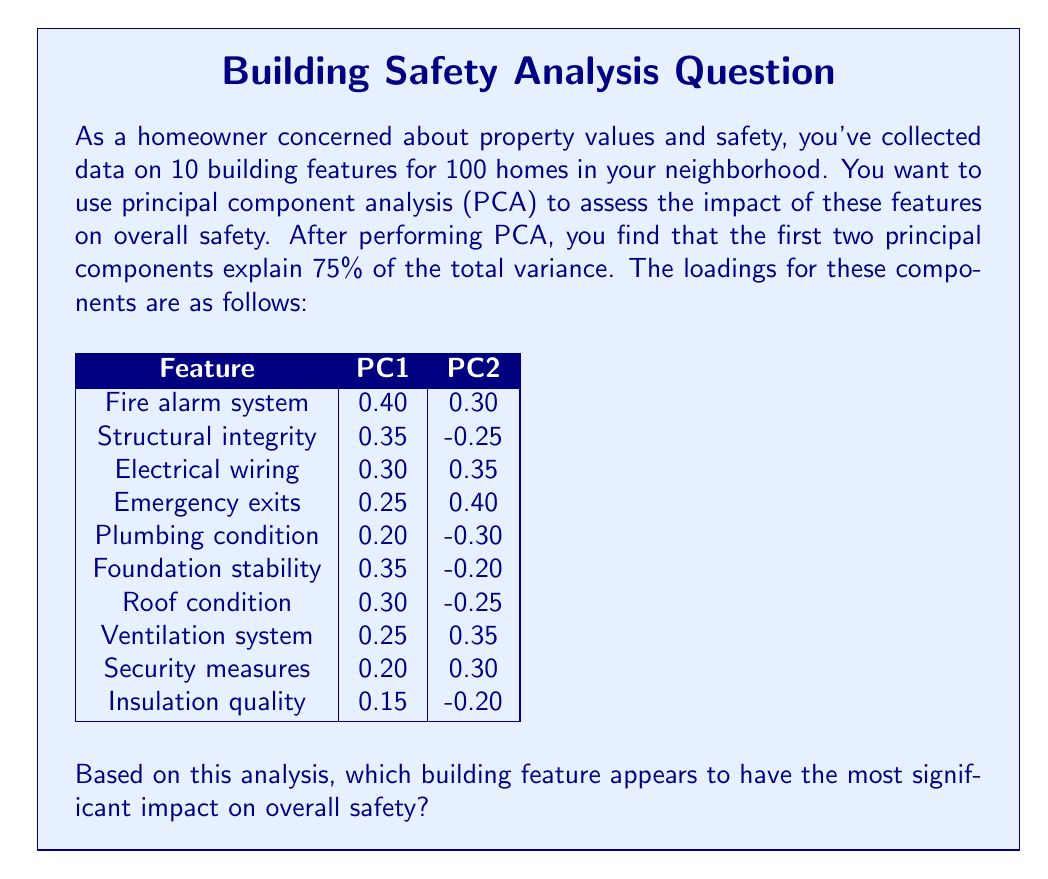Help me with this question. To determine which building feature has the most significant impact on overall safety, we need to analyze the loadings of each feature on the principal components. The loadings represent the correlation between the original features and the principal components.

Steps to solve:

1. Identify the principal component that explains the most variance:
   PC1 typically explains more variance than PC2, so we'll focus on PC1.

2. Find the feature with the highest absolute loading on PC1:
   - Fire alarm system: |0.40|
   - Structural integrity: |0.35|
   - Electrical wiring: |0.30|
   - Emergency exits: |0.25|
   - Plumbing condition: |0.20|
   - Foundation stability: |0.35|
   - Roof condition: |0.30|
   - Ventilation system: |0.25|
   - Security measures: |0.20|
   - Insulation quality: |0.15|

3. The feature with the highest absolute loading on PC1 is the fire alarm system with a loading of 0.40.

4. Interpret the result:
   The fire alarm system has the strongest correlation with PC1, which explains the largest portion of variance in the data. This suggests that the fire alarm system has the most significant impact on overall safety among the features analyzed.

Note: While we focused on PC1, it's worth mentioning that the fire alarm system also has a relatively high loading on PC2 (0.30), further supporting its importance in the overall safety assessment.
Answer: Fire alarm system 